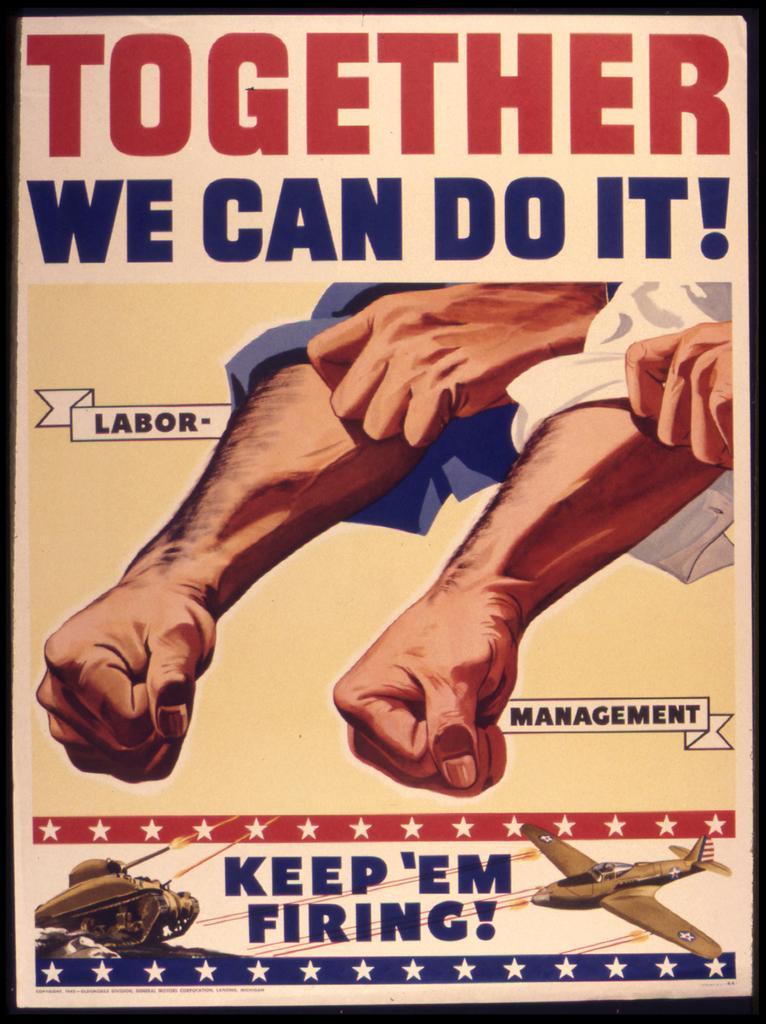In one or two sentences, can you explain what this image depicts? In this image I can see a pamphlet. I can see two hands,aeroplane and something is written on it with different colors. 